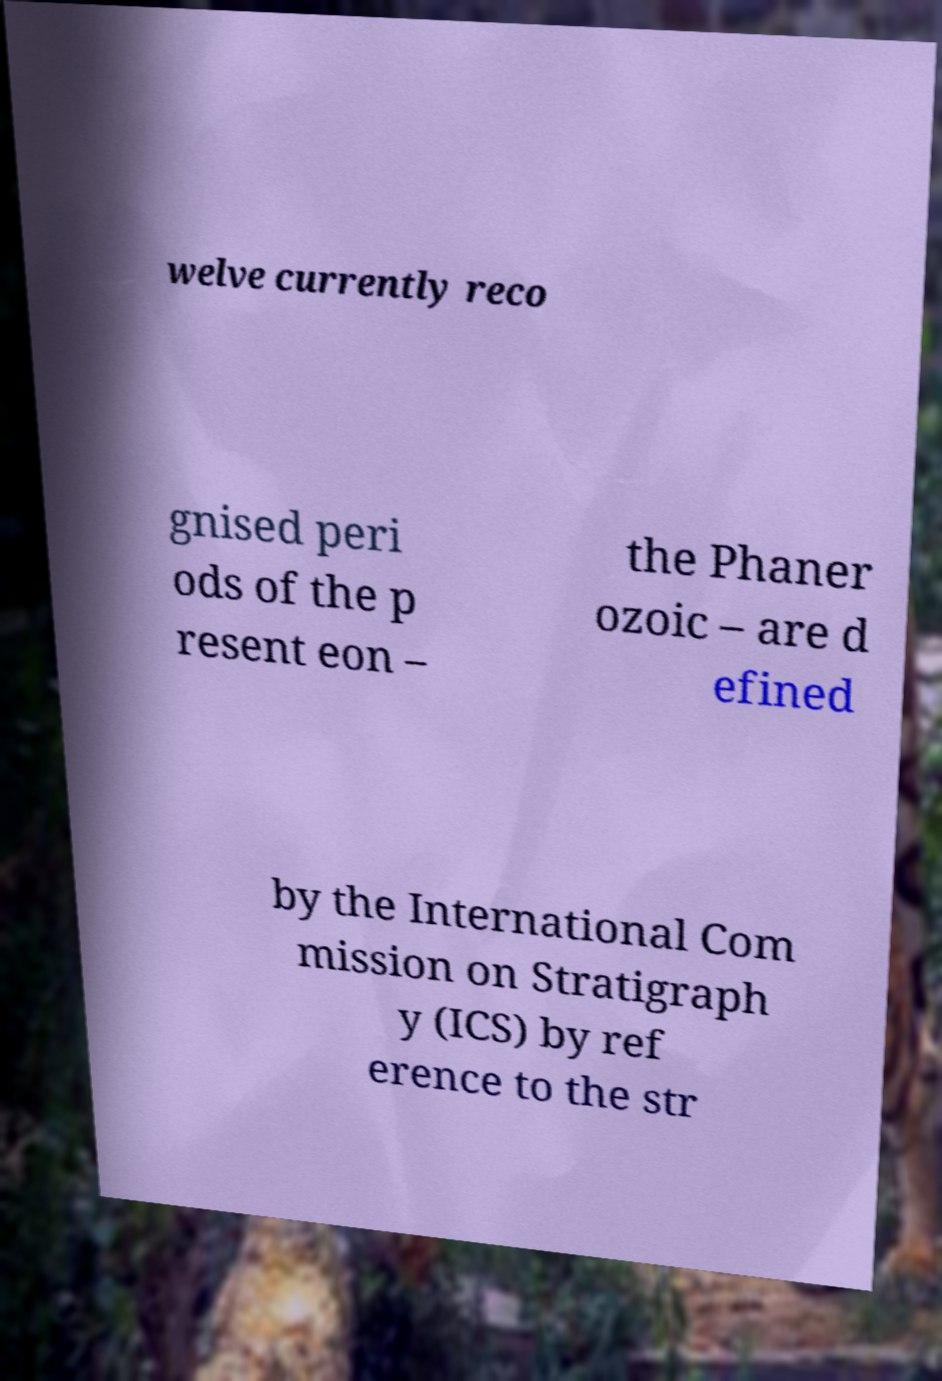Could you extract and type out the text from this image? welve currently reco gnised peri ods of the p resent eon – the Phaner ozoic – are d efined by the International Com mission on Stratigraph y (ICS) by ref erence to the str 